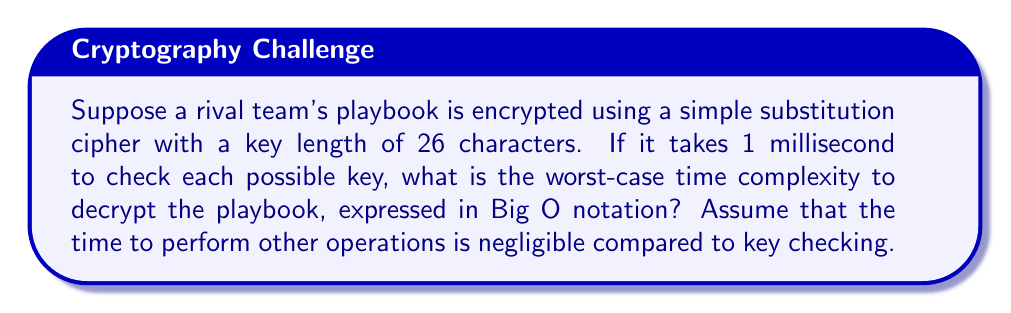What is the answer to this math problem? Let's break this down step-by-step:

1) In a simple substitution cipher with a key length of 26 characters, each character can be any of the 26 letters of the alphabet.

2) This means there are 26! (26 factorial) possible keys.

3) We need to calculate 26!:
   $$26! = 26 \times 25 \times 24 \times ... \times 2 \times 1 \approx 4.03 \times 10^{26}$$

4) If each key check takes 1 millisecond, the total time in milliseconds is:
   $$4.03 \times 10^{26} \text{ milliseconds}$$

5) However, for Big O notation, we're interested in the growth rate, not the exact number. The dominant factor here is 26!, which grows faster than any polynomial function.

6) In cryptography, when dealing with factorial time complexities, we often use the Sterling's approximation:
   $$n! \approx \sqrt{2\pi n} \left(\frac{n}{e}\right)^n$$

7) This approximation shows that n! grows slightly slower than $n^n$ but much faster than $2^n$.

8) Therefore, the time complexity in Big O notation is $O(n!)$, where n is the key length (26 in this case).
Answer: $O(n!)$ 